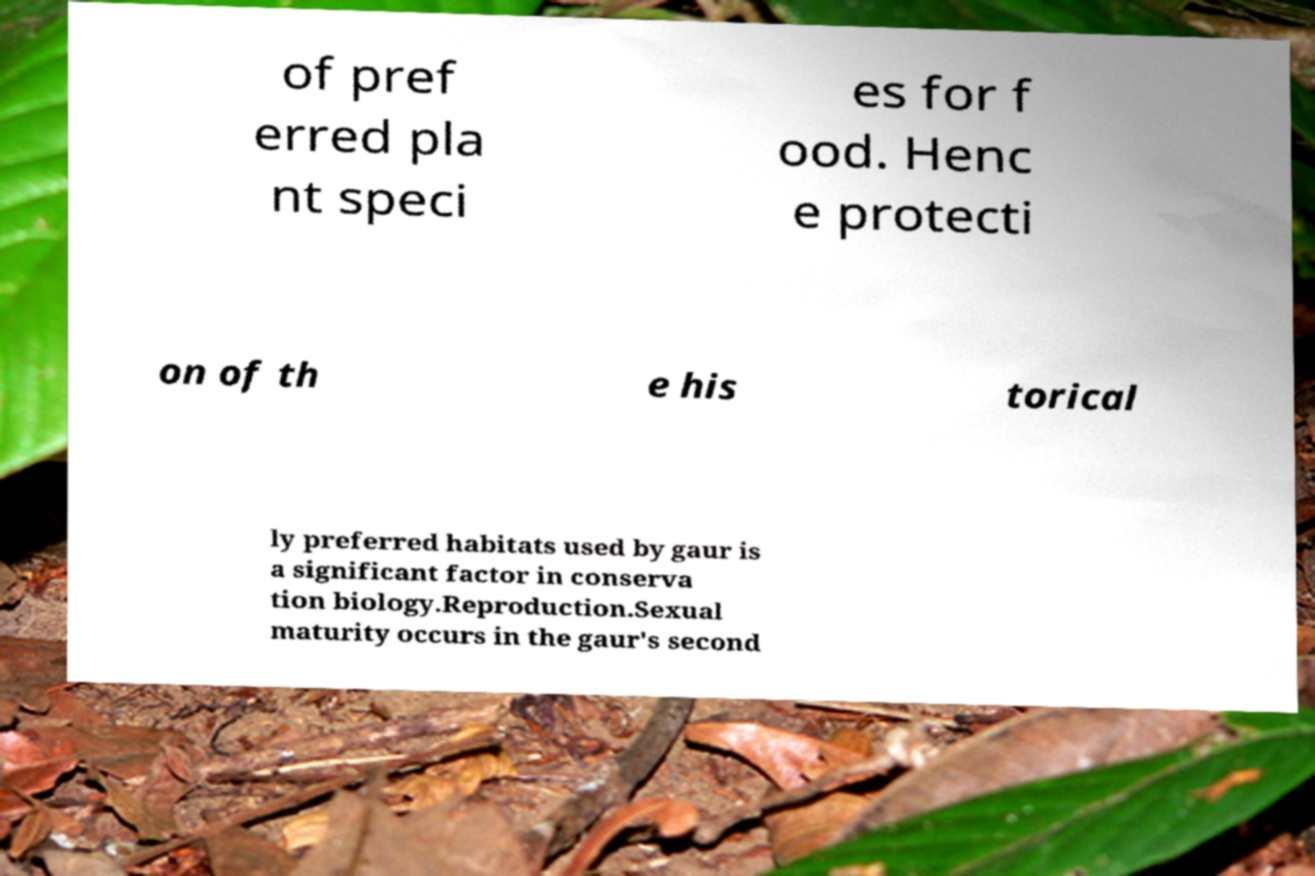What messages or text are displayed in this image? I need them in a readable, typed format. of pref erred pla nt speci es for f ood. Henc e protecti on of th e his torical ly preferred habitats used by gaur is a significant factor in conserva tion biology.Reproduction.Sexual maturity occurs in the gaur's second 